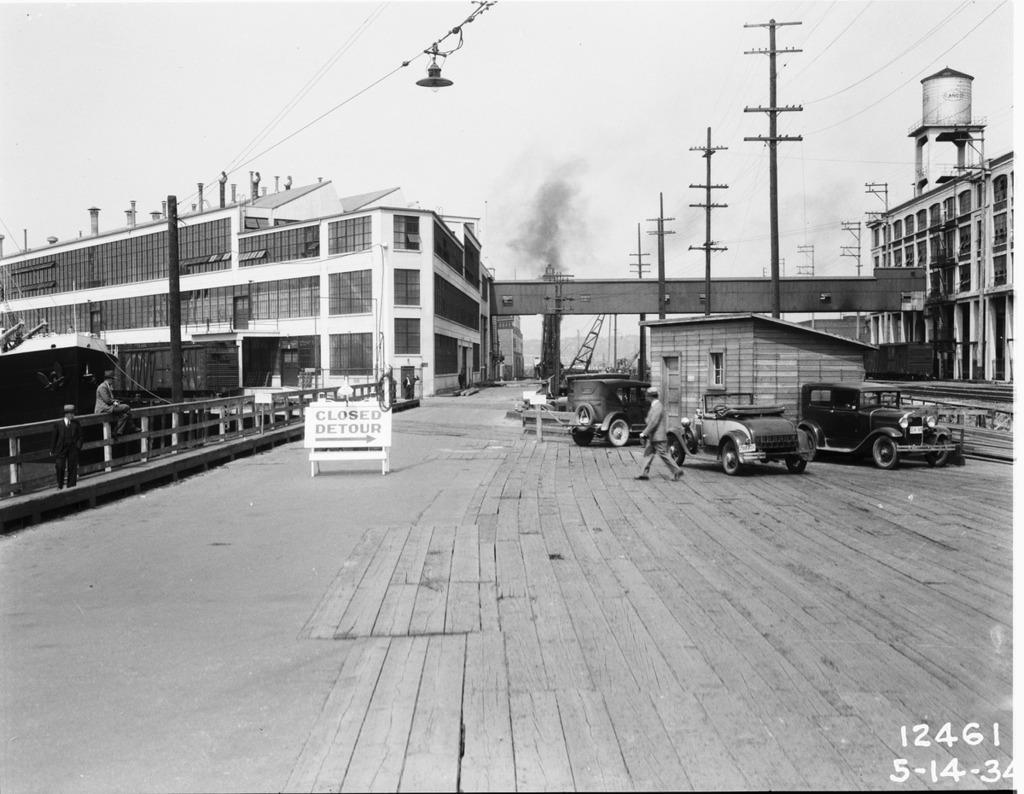Describe this image in one or two sentences. This image is black and white in color. In the image we can see there are buildings, these are the electric poles and electric wires, we can even see there are vehicles. This is a fence, footpath, board and text on it, smoke and a sky. We can see there are even people wearing clothes. 